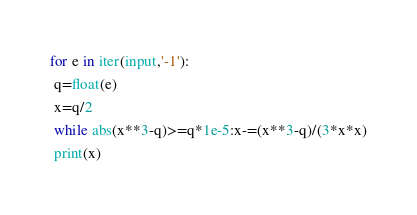Convert code to text. <code><loc_0><loc_0><loc_500><loc_500><_Python_>for e in iter(input,'-1'):
 q=float(e)
 x=q/2
 while abs(x**3-q)>=q*1e-5:x-=(x**3-q)/(3*x*x)
 print(x)
</code> 